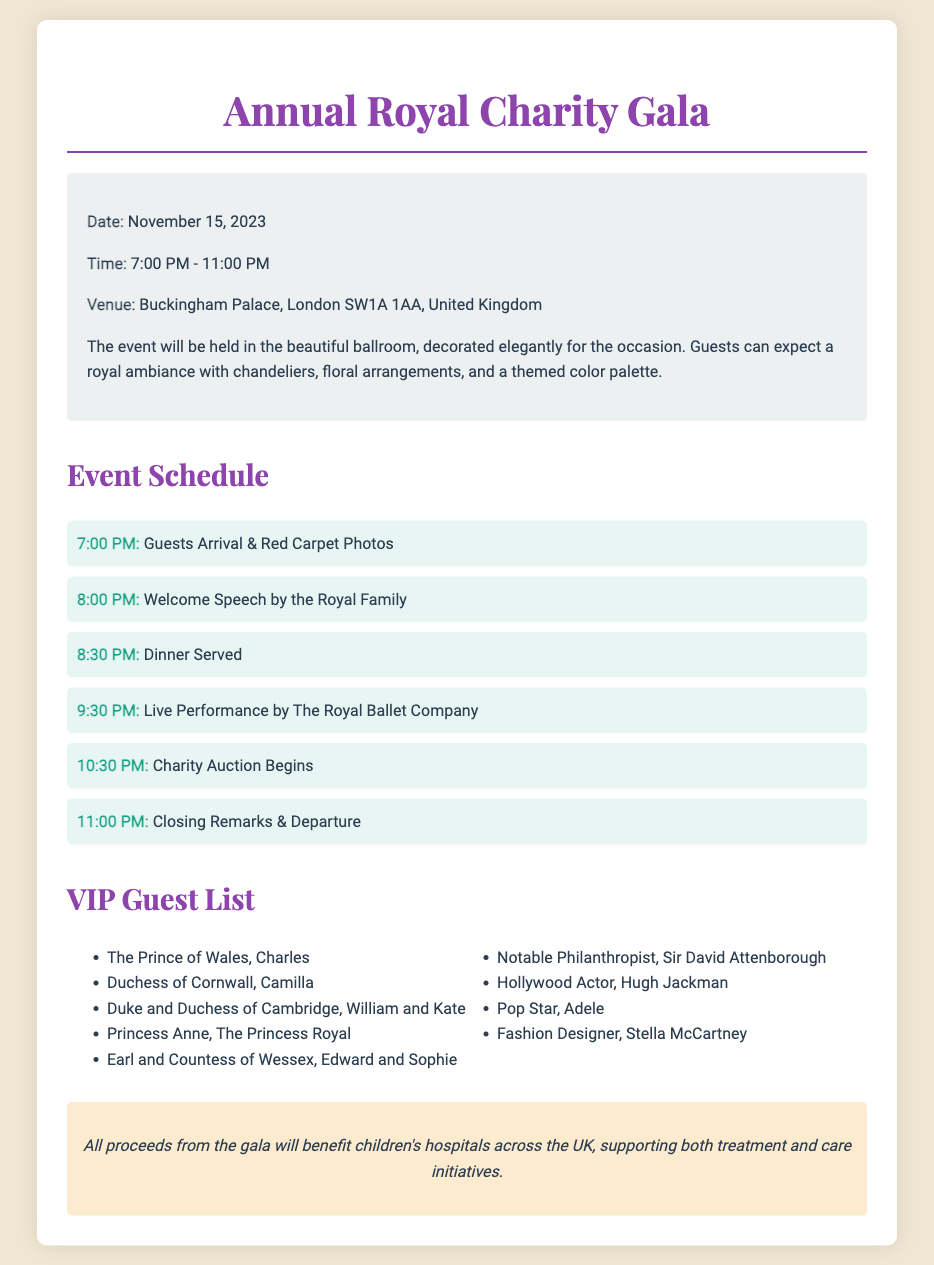What is the date of the gala? The date is specified in the document as November 15, 2023.
Answer: November 15, 2023 What time does the charity auction begin? The schedule lists the charity auction as starting at 10:30 PM.
Answer: 10:30 PM Where is the venue located? The document provides the venue information as Buckingham Palace, London SW1A 1AA, United Kingdom.
Answer: Buckingham Palace, London SW1A 1AA, United Kingdom Who will perform live at the event? The schedule mentions that The Royal Ballet Company will be performing live.
Answer: The Royal Ballet Company How many VIP guests are listed? The document includes a list of 9 notable VIP guests attending the gala.
Answer: 9 What is the main focus of the charity gala? The document states that proceeds will benefit children's hospitals across the UK.
Answer: Children's hospitals What event occurs right after the welcome speech? According to the schedule, dinner is served after the welcome speech.
Answer: Dinner Served What is the closing time of the event? The document specifies that the event will close at 11:00 PM with closing remarks.
Answer: 11:00 PM Who is a notable philanthropist attending the gala? The document mentions Sir David Attenborough as a notable philanthropist.
Answer: Sir David Attenborough 